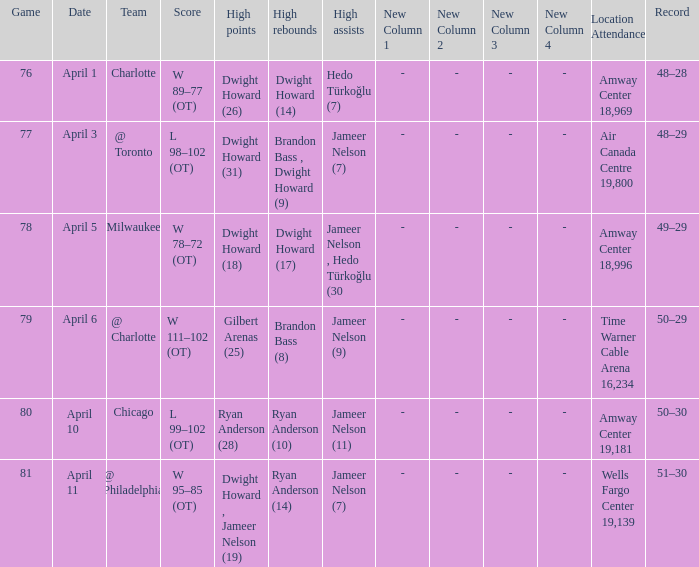Who had the most the most rebounds and how many did they have on April 1? Dwight Howard (14). 